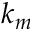Convert formula to latex. <formula><loc_0><loc_0><loc_500><loc_500>k _ { m }</formula> 